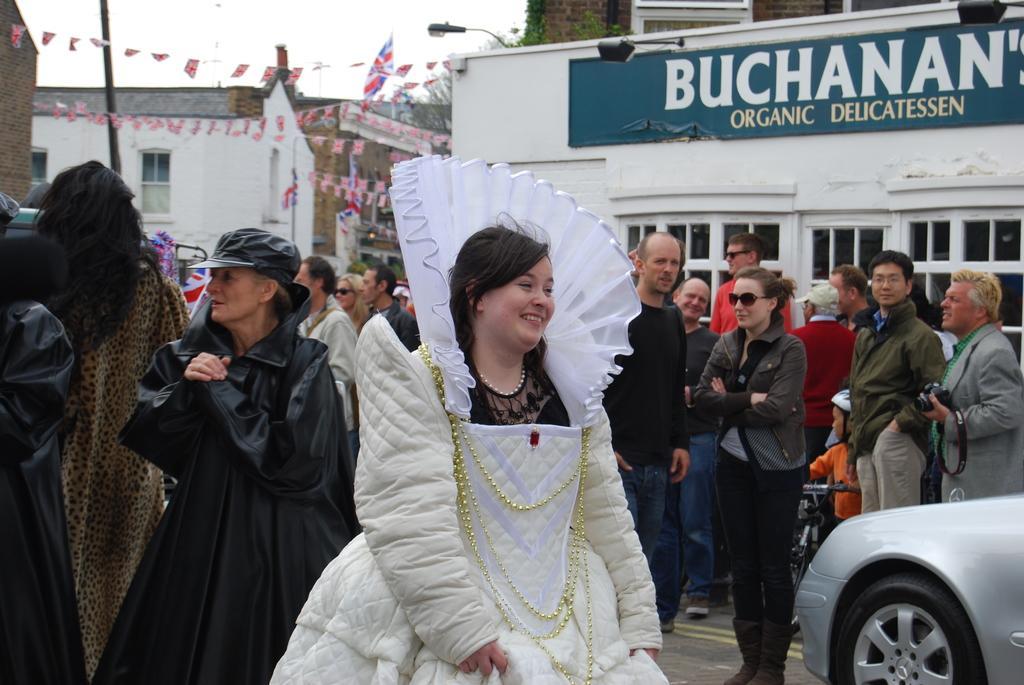How would you summarize this image in a sentence or two? In this image we can see a woman standing on the road. We can also see a group of people standing behind her, a child holding a bicycle, a person holding a camera and a car on the road. On the right side we can see a building with board, windows, lights and plant. On the left side we can see a pole, buildings, flags and the sky. 